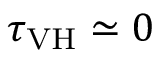Convert formula to latex. <formula><loc_0><loc_0><loc_500><loc_500>\tau _ { V H } \simeq 0</formula> 